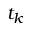Convert formula to latex. <formula><loc_0><loc_0><loc_500><loc_500>t _ { k }</formula> 